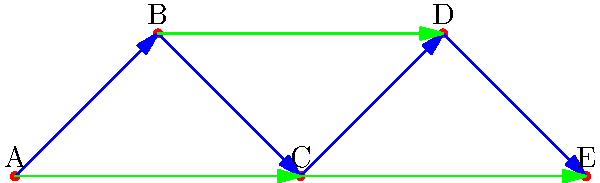While cleaning the State Capitol building, you come across a document showing a Cayley graph of communication patterns between government officials A, B, C, D, and E. Blue arrows represent direct communication, while green arrows represent indirect communication through intermediaries. What is the order of the group represented by this Cayley graph, and what type of group structure does it suggest? To determine the order and structure of the group represented by this Cayley graph, we need to analyze its properties:

1. Count the vertices: There are 5 vertices (A, B, C, D, E), representing 5 government officials.

2. Examine the edges:
   - Blue arrows show direct communication between adjacent officials.
   - Green arrows show indirect communication, skipping one official.

3. Identify the generators:
   - The blue arrows suggest a generator that moves from one official to the next (cyclic rotation).
   - The green arrows suggest a generator that moves two steps at a time.

4. Determine the group structure:
   - The graph shows a cyclic structure, as we can reach any vertex from any other by following the arrows.
   - The number of vertices (5) is prime, which is significant for cyclic groups.

5. Conclude the group type:
   - The group is cyclic of order 5, denoted as $C_5$ or $\mathbb{Z}_5$.
   - This is because we can generate all elements by repeated application of a single generator (rotating by one position).

6. Verify the Cayley graph properties:
   - The graph is connected (we can reach any vertex from any other).
   - The graph is regular (each vertex has the same number of incoming and outgoing edges).
   - The graph exhibits symmetry, which is characteristic of Cayley graphs.

Therefore, the order of the group is 5, and the structure suggests a cyclic group of order 5.
Answer: Order 5, cyclic group $C_5$ 